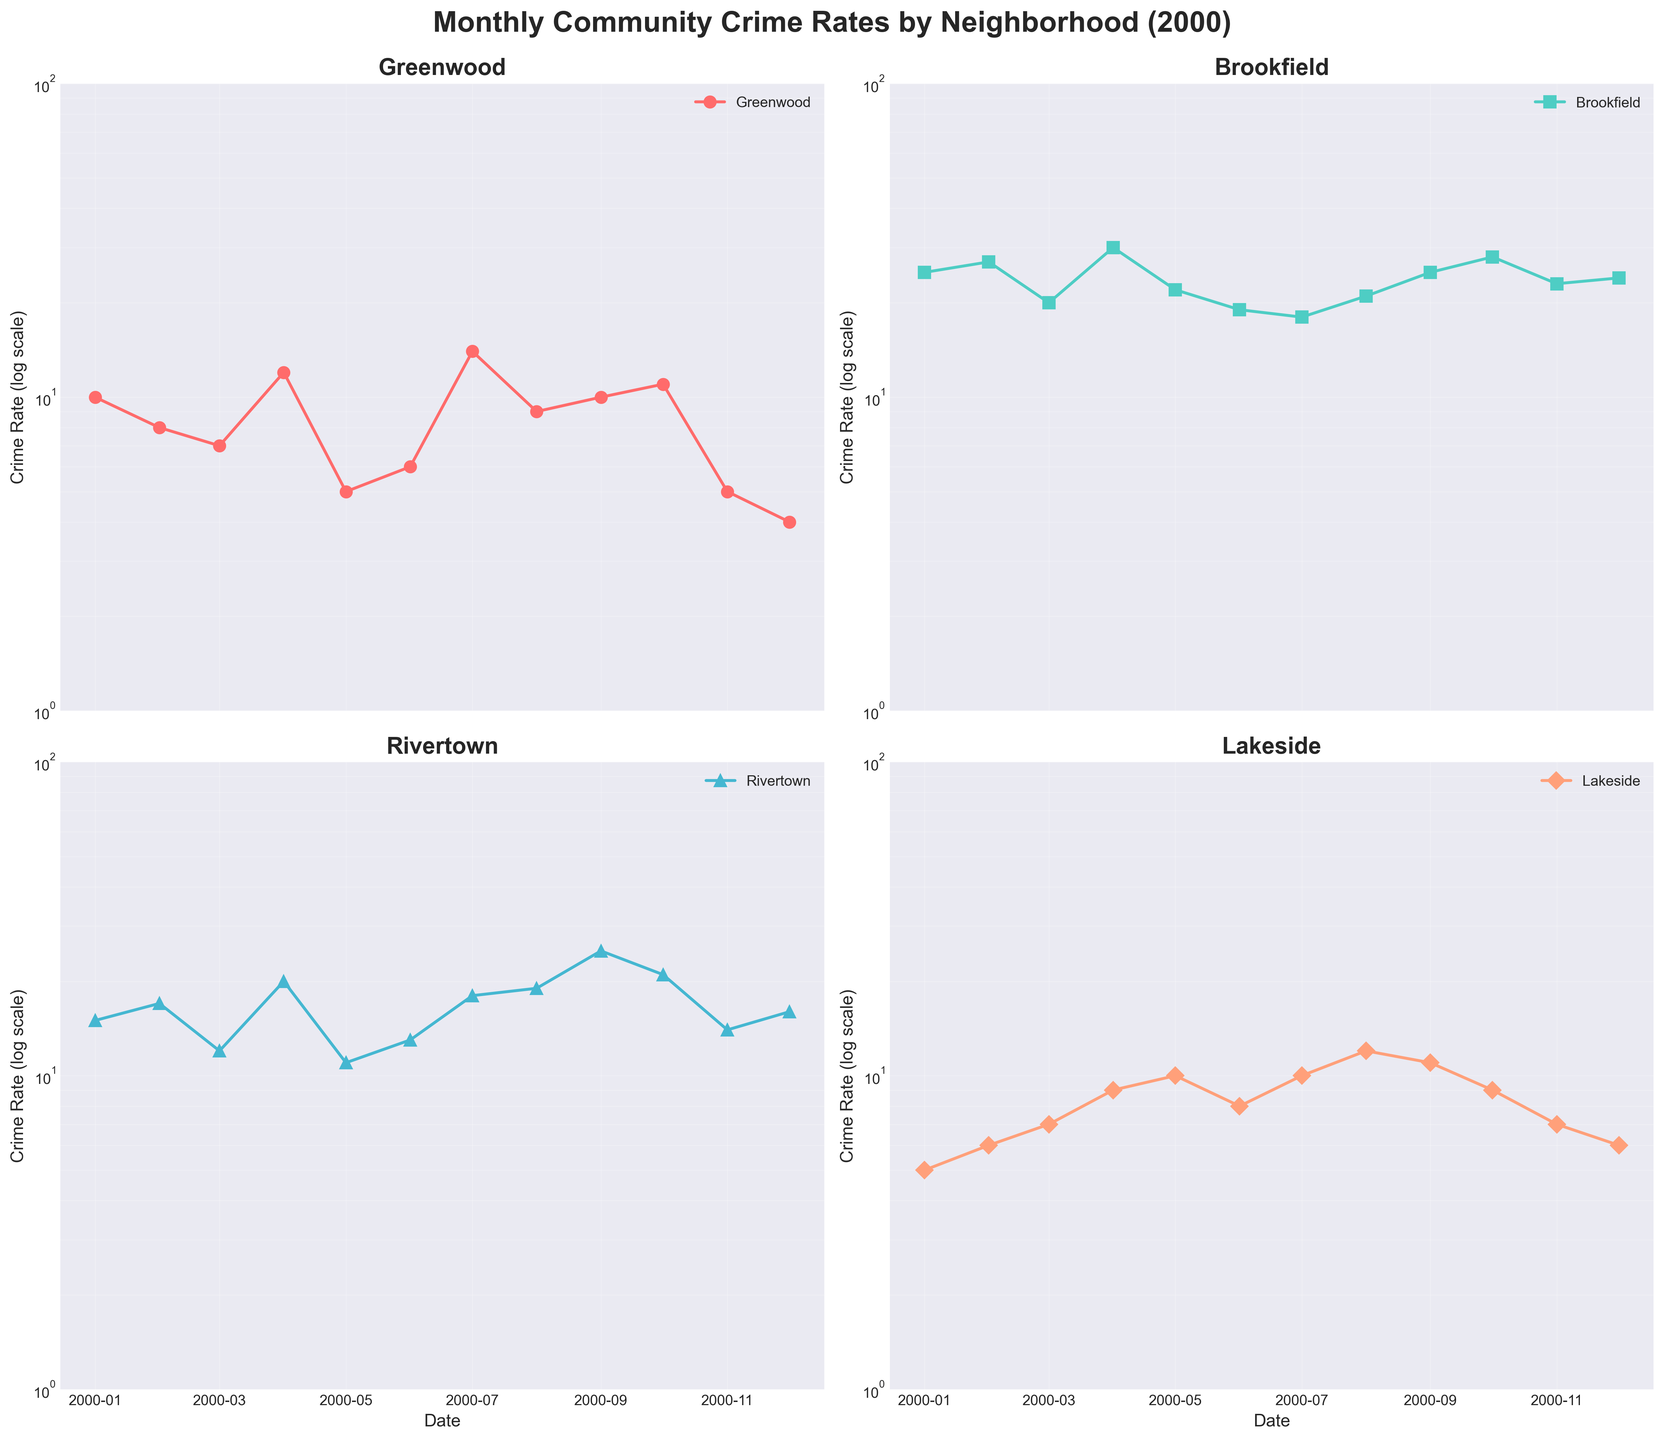Does Greenwood's crime rate show an overall increasing or decreasing trend across the year 2000? By analyzing the plot for Greenwood, observe the overall pattern from January to December. The general trend shows a decrease from January to May, then fluctuates till December.
Answer: Decreasing Which neighborhood had the highest crime rate in July 2000? Look at the data points for July 2000 across all subplots. Greenwood (14), Brookfield (18), Rivertown (18), Lakeside (10). Both Brookfield and Rivertown have the highest rate at 18.
Answer: Brookfield and Rivertown What is the smallest crime rate recorded in Brookfield, and in which month did this occur? Examine the data points for Brookfield's subplot. The lowest crime rate is 18, which occurs in June and July.
Answer: 18 in June and July By how much did Rivertown’s crime rate change from January to December 2000? Note the Rivertown crime rate in January (15) and in December (16). Compute the difference: 16 - 15 = 1.
Answer: Increase by 1 Between Greenwood and Lakeside, which neighborhood saw a greater variability in crime rates over the year? Greenwood's crime rates range from 4 to 14, while Lakeside's range from 5 to 12. The range for Greenwood is 14 - 4 = 10 and for Lakeside is 12 - 5 = 7. Greenwood has a larger variability.
Answer: Greenwood What is the range of crime rates in Lakeside throughout the year 2000? Look at the lowest and highest crime rates for Lakeside. The range is calculated by subtracting the lowest value (5) from the highest value (12): 12 - 5.
Answer: 7 Which neighborhood has consistently higher crime rates, Rivertown or Greenwood? Compare the data points for Rivertown and Greenwood across the year. Rivertown generally has higher rates than Greenwood.
Answer: Rivertown How many months did Greenwood have a crime rate below 10? Count the points below 10 on Greenwood's subplot: February, March, May, June, August, November, December.
Answer: 7 months What months saw the highest and lowest crime rates for Lakeside? Identify the peak and trough values for Lakeside. Highest in August (12), lowest in January and December (5).
Answer: Highest in August, Lowest in January and December 